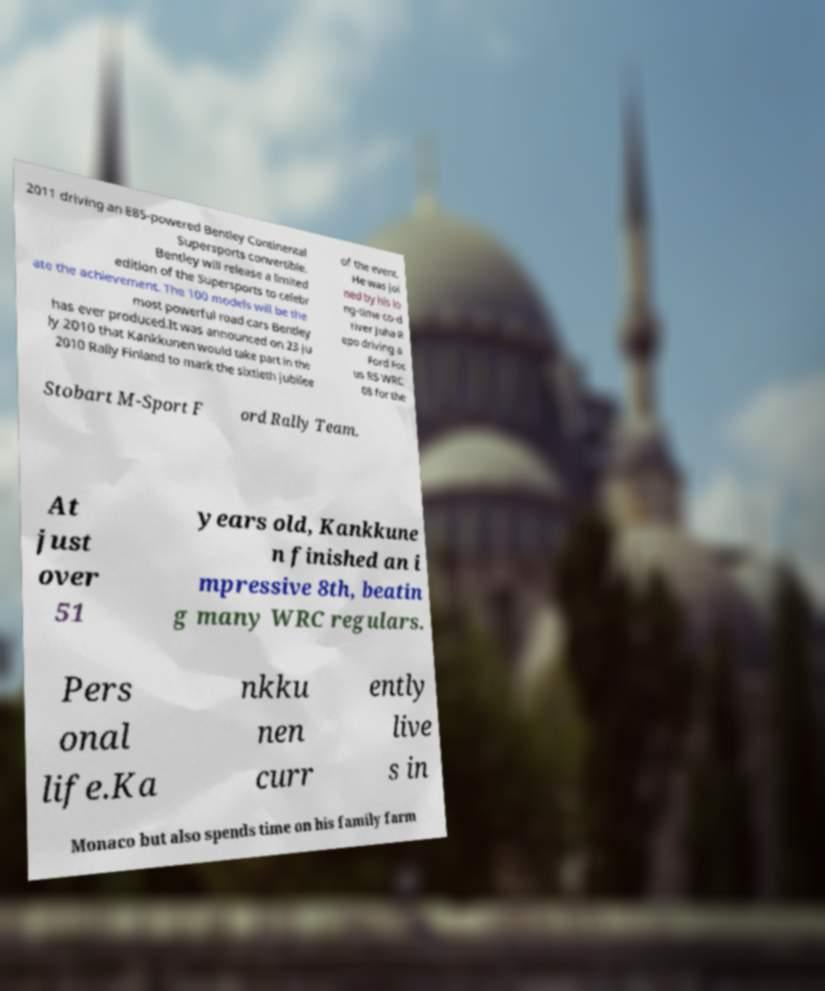There's text embedded in this image that I need extracted. Can you transcribe it verbatim? 2011 driving an E85-powered Bentley Continental Supersports convertible. Bentley will release a limited edition of the Supersports to celebr ate the achievement. The 100 models will be the most powerful road cars Bentley has ever produced.It was announced on 23 Ju ly 2010 that Kankkunen would take part in the 2010 Rally Finland to mark the sixtieth jubilee of the event. He was joi ned by his lo ng-time co-d river Juha R epo driving a Ford Foc us RS WRC 08 for the Stobart M-Sport F ord Rally Team. At just over 51 years old, Kankkune n finished an i mpressive 8th, beatin g many WRC regulars. Pers onal life.Ka nkku nen curr ently live s in Monaco but also spends time on his family farm 